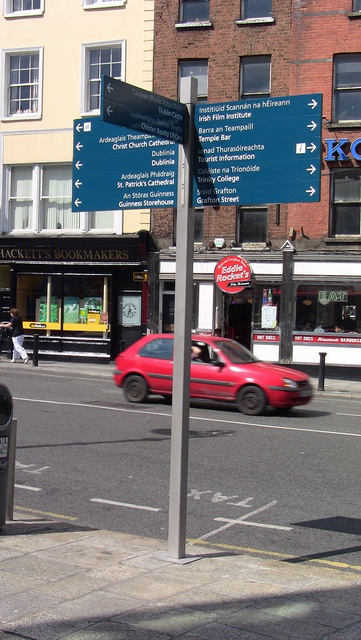Describe the objects in this image and their specific colors. I can see train in white, black, gray, and darkgray tones, car in white, black, gray, salmon, and red tones, people in white, black, lavender, and gray tones, people in white, black, and gray tones, and people in white, black, and gray tones in this image. 